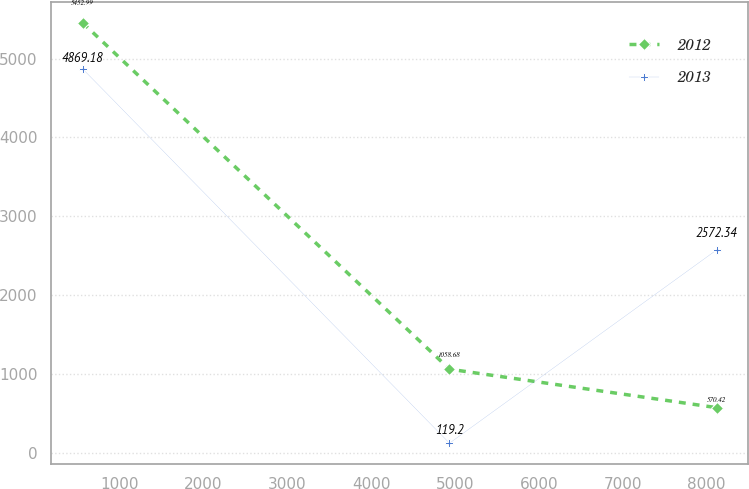<chart> <loc_0><loc_0><loc_500><loc_500><line_chart><ecel><fcel>2012<fcel>2013<nl><fcel>558.03<fcel>5452.99<fcel>4869.18<nl><fcel>4933.76<fcel>1058.68<fcel>119.2<nl><fcel>8121.36<fcel>570.42<fcel>2572.34<nl></chart> 